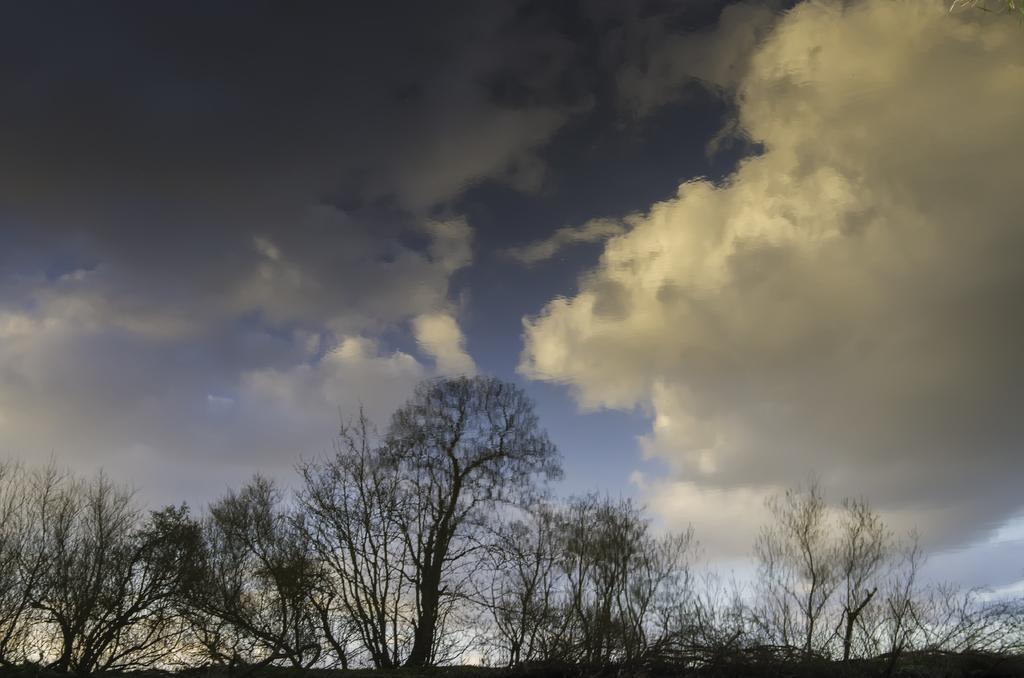What type of vegetation is present on the ground in the image? There are trees on the ground in the image. What can be seen in the sky in the background? There are clouds in the sky in the background. What type of snack is being passed around by the elbow in the image? There is no snack or elbow present in the image. Is there any blood visible in the image? No, there is no blood visible in the image. 